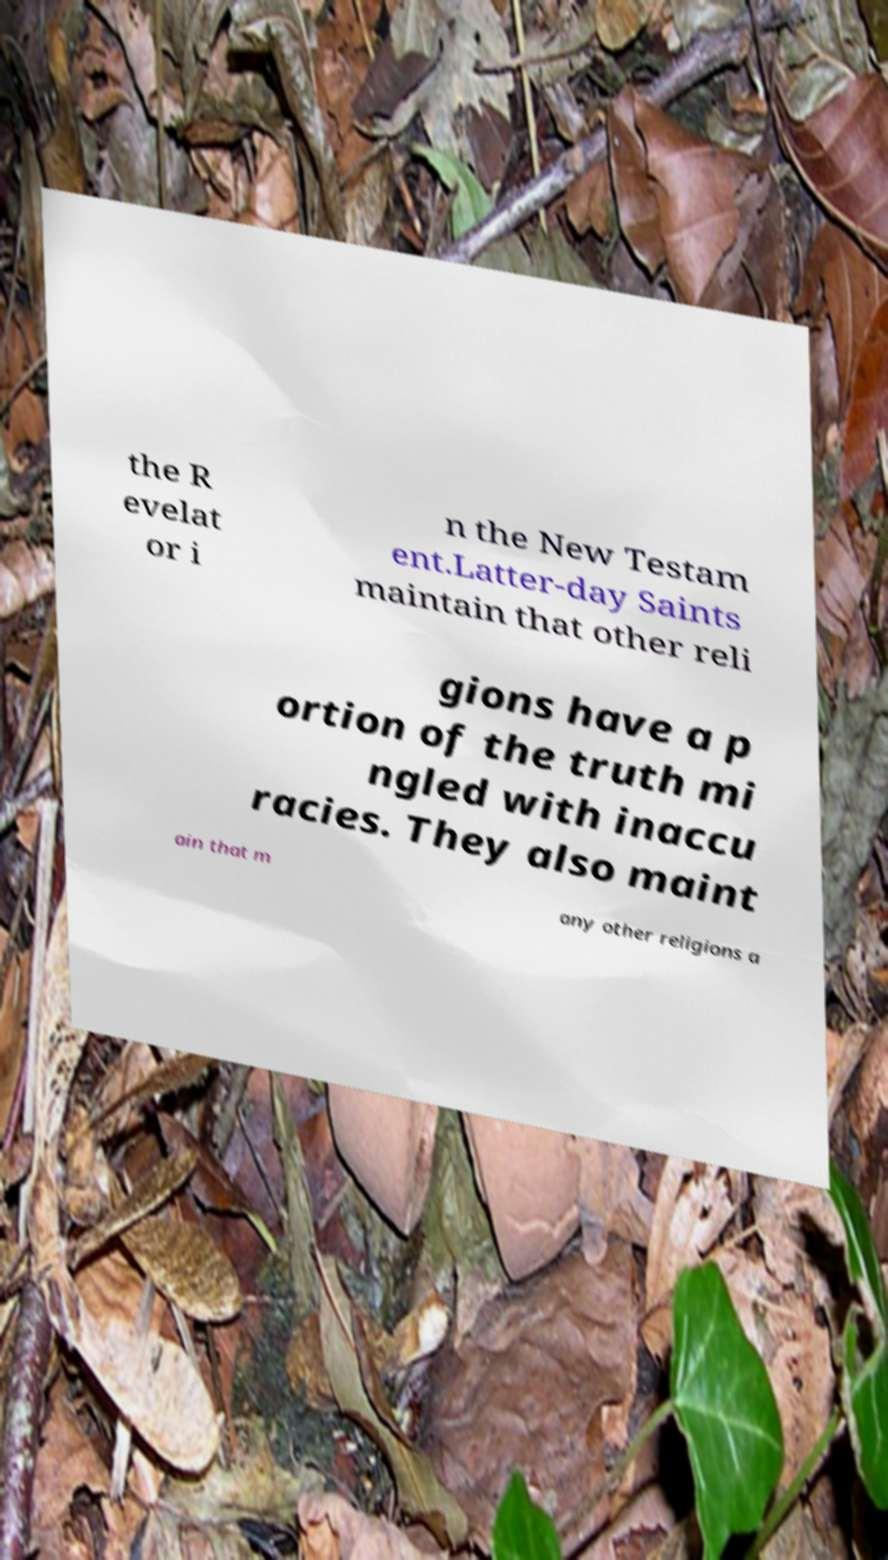Could you extract and type out the text from this image? the R evelat or i n the New Testam ent.Latter-day Saints maintain that other reli gions have a p ortion of the truth mi ngled with inaccu racies. They also maint ain that m any other religions a 